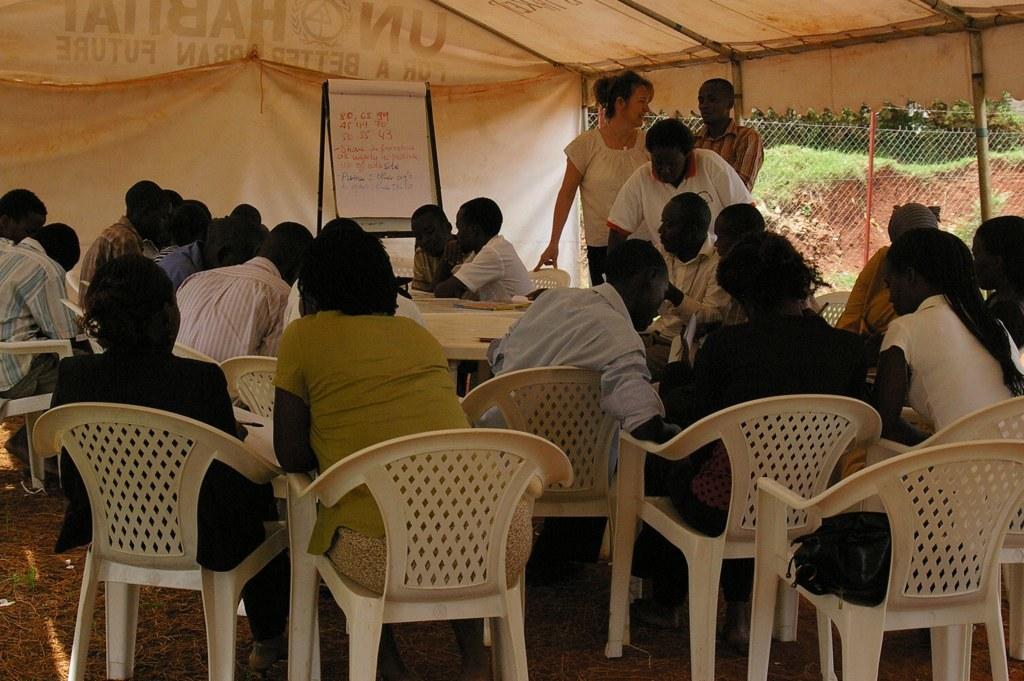How would you summarize this image in a sentence or two? In this picture there is a table and a board in the center of the image and there are people those who are sitting on the chairs at the bottom side of the image, there are trees and a net boundary on the right side of the image. 